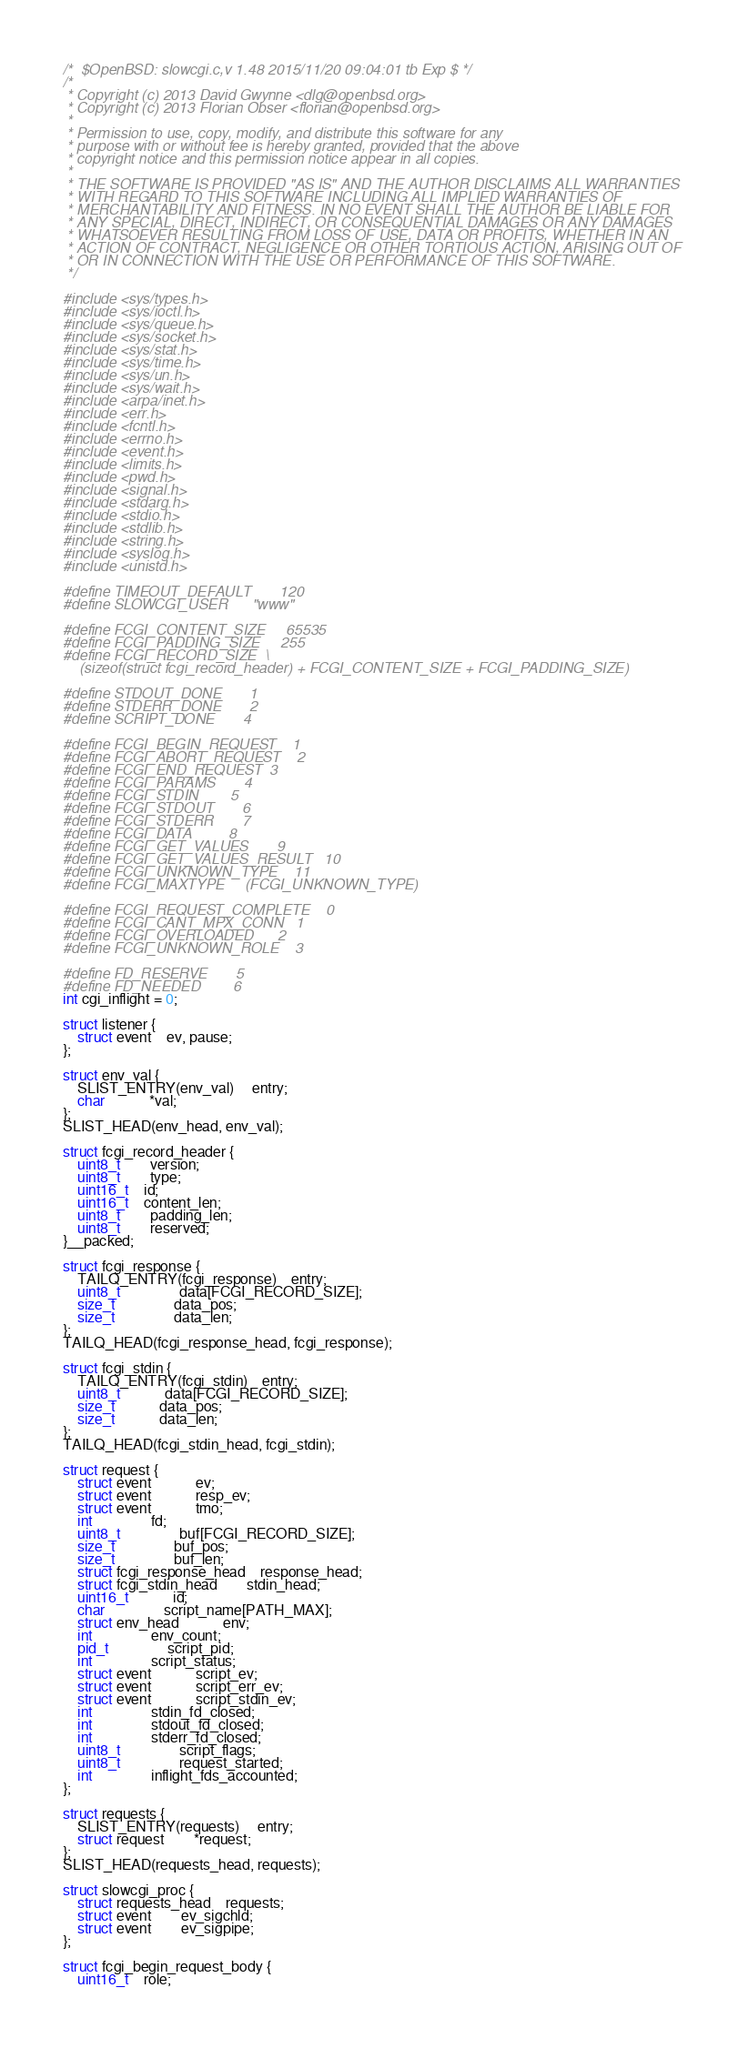Convert code to text. <code><loc_0><loc_0><loc_500><loc_500><_C_>/*	$OpenBSD: slowcgi.c,v 1.48 2015/11/20 09:04:01 tb Exp $ */
/*
 * Copyright (c) 2013 David Gwynne <dlg@openbsd.org>
 * Copyright (c) 2013 Florian Obser <florian@openbsd.org>
 *
 * Permission to use, copy, modify, and distribute this software for any
 * purpose with or without fee is hereby granted, provided that the above
 * copyright notice and this permission notice appear in all copies.
 *
 * THE SOFTWARE IS PROVIDED "AS IS" AND THE AUTHOR DISCLAIMS ALL WARRANTIES
 * WITH REGARD TO THIS SOFTWARE INCLUDING ALL IMPLIED WARRANTIES OF
 * MERCHANTABILITY AND FITNESS. IN NO EVENT SHALL THE AUTHOR BE LIABLE FOR
 * ANY SPECIAL, DIRECT, INDIRECT, OR CONSEQUENTIAL DAMAGES OR ANY DAMAGES
 * WHATSOEVER RESULTING FROM LOSS OF USE, DATA OR PROFITS, WHETHER IN AN
 * ACTION OF CONTRACT, NEGLIGENCE OR OTHER TORTIOUS ACTION, ARISING OUT OF
 * OR IN CONNECTION WITH THE USE OR PERFORMANCE OF THIS SOFTWARE.
 */

#include <sys/types.h>
#include <sys/ioctl.h>
#include <sys/queue.h>
#include <sys/socket.h>
#include <sys/stat.h>
#include <sys/time.h>
#include <sys/un.h>
#include <sys/wait.h>
#include <arpa/inet.h>
#include <err.h>
#include <fcntl.h>
#include <errno.h>
#include <event.h>
#include <limits.h>
#include <pwd.h>
#include <signal.h>
#include <stdarg.h>
#include <stdio.h>
#include <stdlib.h>
#include <string.h>
#include <syslog.h>
#include <unistd.h>

#define TIMEOUT_DEFAULT		 120
#define SLOWCGI_USER		 "www"

#define FCGI_CONTENT_SIZE	 65535
#define FCGI_PADDING_SIZE	 255
#define FCGI_RECORD_SIZE	 \
    (sizeof(struct fcgi_record_header) + FCGI_CONTENT_SIZE + FCGI_PADDING_SIZE)

#define STDOUT_DONE		 1
#define STDERR_DONE		 2
#define SCRIPT_DONE		 4

#define FCGI_BEGIN_REQUEST	 1
#define FCGI_ABORT_REQUEST	 2
#define FCGI_END_REQUEST	 3
#define FCGI_PARAMS		 4
#define FCGI_STDIN		 5
#define FCGI_STDOUT		 6
#define FCGI_STDERR		 7
#define FCGI_DATA		 8
#define FCGI_GET_VALUES		 9
#define FCGI_GET_VALUES_RESULT	10
#define FCGI_UNKNOWN_TYPE	11
#define FCGI_MAXTYPE		(FCGI_UNKNOWN_TYPE)

#define FCGI_REQUEST_COMPLETE	0
#define FCGI_CANT_MPX_CONN	1
#define FCGI_OVERLOADED		2
#define FCGI_UNKNOWN_ROLE	3

#define FD_RESERVE		5
#define FD_NEEDED		6
int cgi_inflight = 0;

struct listener {
	struct event	ev, pause;
};

struct env_val {
	SLIST_ENTRY(env_val)	 entry;
	char			*val;
};
SLIST_HEAD(env_head, env_val);

struct fcgi_record_header {
	uint8_t		version;
	uint8_t		type;
	uint16_t	id;
	uint16_t	content_len;
	uint8_t		padding_len;
	uint8_t		reserved;
}__packed;

struct fcgi_response {
	TAILQ_ENTRY(fcgi_response)	entry;
	uint8_t				data[FCGI_RECORD_SIZE];
	size_t				data_pos;
	size_t				data_len;
};
TAILQ_HEAD(fcgi_response_head, fcgi_response);

struct fcgi_stdin {
	TAILQ_ENTRY(fcgi_stdin)	entry;
	uint8_t			data[FCGI_RECORD_SIZE];
	size_t			data_pos;
	size_t			data_len;
};
TAILQ_HEAD(fcgi_stdin_head, fcgi_stdin);

struct request {
	struct event			ev;
	struct event			resp_ev;
	struct event			tmo;
	int				fd;
	uint8_t				buf[FCGI_RECORD_SIZE];
	size_t				buf_pos;
	size_t				buf_len;
	struct fcgi_response_head	response_head;
	struct fcgi_stdin_head		stdin_head;
	uint16_t			id;
	char				script_name[PATH_MAX];
	struct env_head			env;
	int				env_count;
	pid_t				script_pid;
	int				script_status;
	struct event			script_ev;
	struct event			script_err_ev;
	struct event			script_stdin_ev;
	int				stdin_fd_closed;
	int				stdout_fd_closed;
	int				stderr_fd_closed;
	uint8_t				script_flags;
	uint8_t				request_started;
	int				inflight_fds_accounted;
};

struct requests {
	SLIST_ENTRY(requests)	 entry;
	struct request		*request;
};
SLIST_HEAD(requests_head, requests);

struct slowcgi_proc {
	struct requests_head	requests;
	struct event		ev_sigchld;
	struct event		ev_sigpipe;
};

struct fcgi_begin_request_body {
	uint16_t	role;</code> 